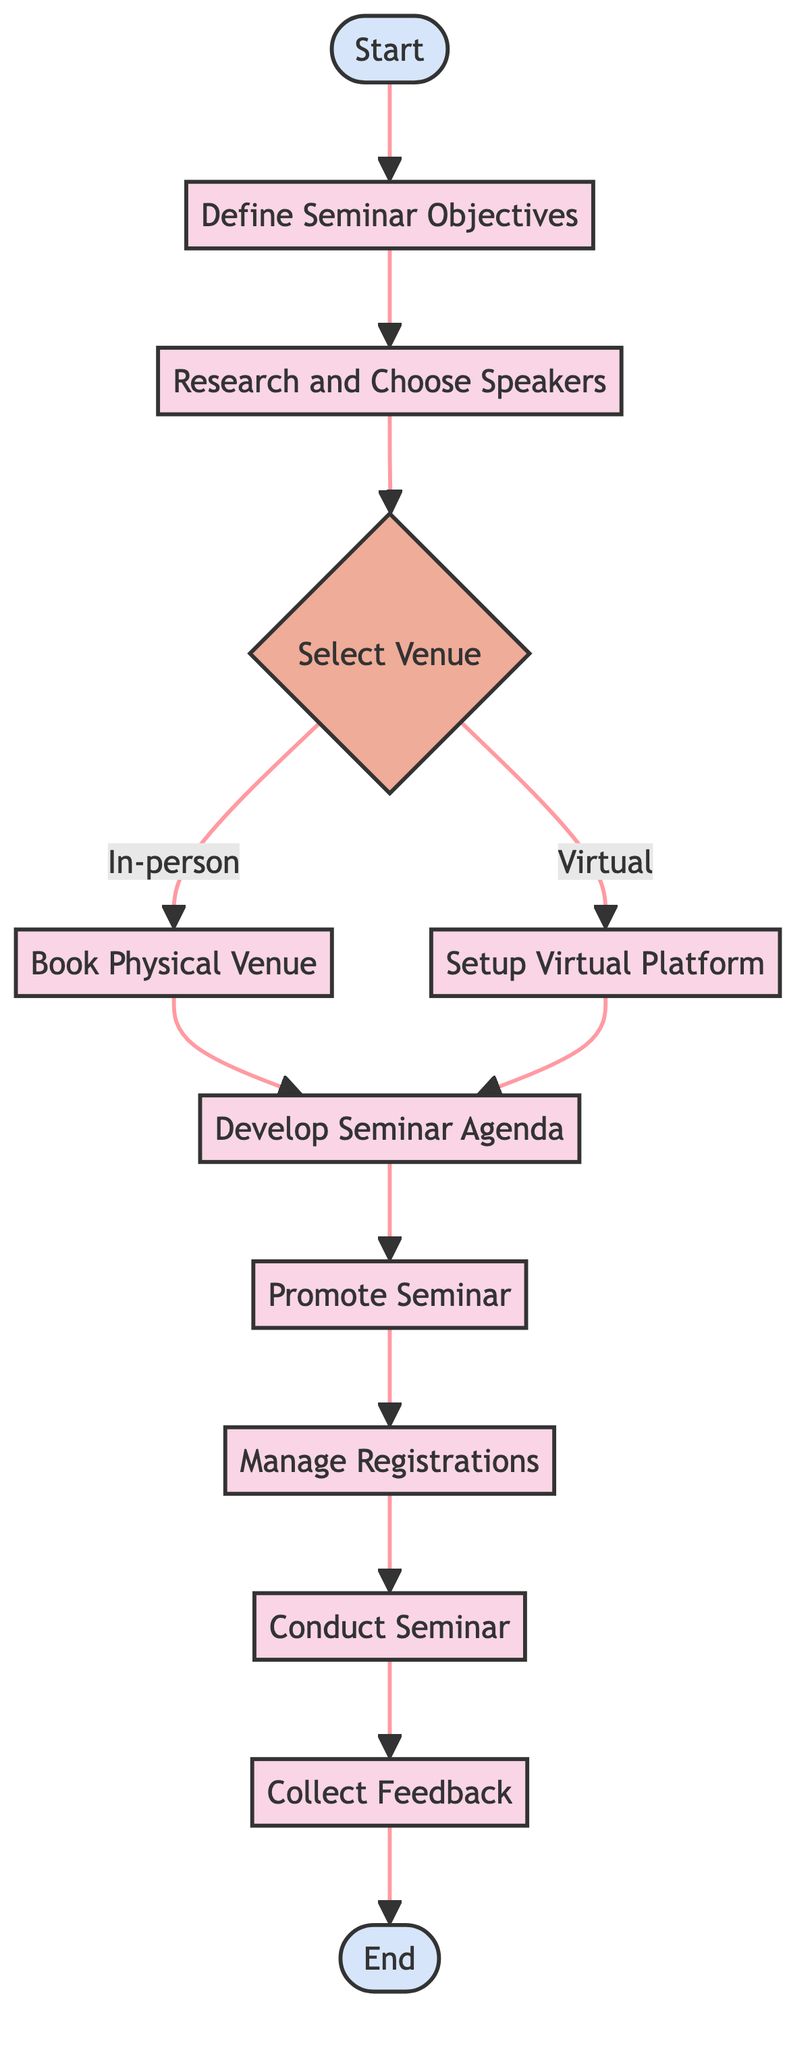What is the starting point of the seminar organization process? The starting point is the "Start" node, which initiates the flowchart.
Answer: Start How many main processes are involved after defining seminar objectives? After defining seminar objectives, there are five main processes: researching speakers, selecting the venue, developing the agenda, promoting the seminar, and managing registrations.
Answer: Five What are the two options available for selecting a venue? The two options for selecting a venue are "In-person" and "Virtual."
Answer: In-person, Virtual What happens after the decision made on the venue? After the venue decision, the next step is to either book the physical venue (if in-person) or set up the virtual platform (if virtual).
Answer: Book Physical Venue, Setup Virtual Platform What is the last step in the seminar organization process? The last step is to "Collect Feedback" from participants.
Answer: Collect Feedback Which processes are performed before promoting the seminar? Before promoting the seminar, the processes of defining objectives, researching speakers, selecting a venue, and developing the agenda must be completed.
Answer: Define Seminar Objectives, Research and Choose Speakers, Select Venue, Develop Seminar Agenda How many decision points are present in the flowchart? There is one decision point in the flowchart, which pertains to selecting the venue.
Answer: One If the venue chosen is virtual, which node follows after that? If the venue chosen is virtual, the next node that follows is "Setup Virtual Platform."
Answer: Setup Virtual Platform What action is required immediately after managing registrations? Immediately after managing registrations, the action required is to "Conduct Seminar."
Answer: Conduct Seminar 